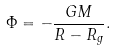<formula> <loc_0><loc_0><loc_500><loc_500>\Phi = - \frac { G M } { R - R _ { g } } .</formula> 